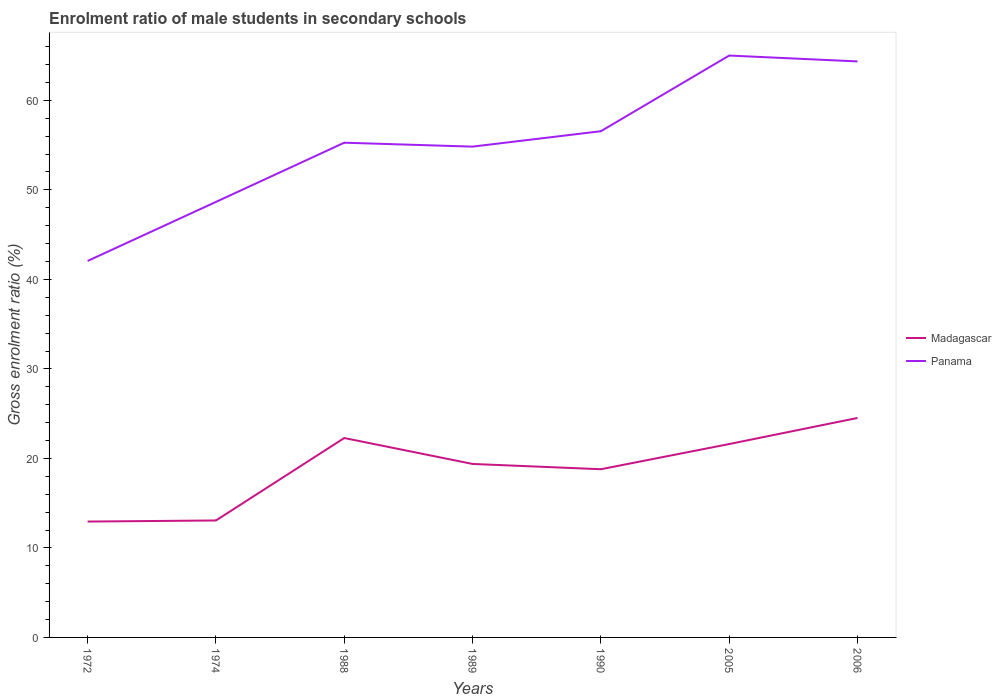How many different coloured lines are there?
Provide a succinct answer. 2. Does the line corresponding to Panama intersect with the line corresponding to Madagascar?
Your answer should be compact. No. Across all years, what is the maximum enrolment ratio of male students in secondary schools in Panama?
Provide a succinct answer. 42.06. In which year was the enrolment ratio of male students in secondary schools in Madagascar maximum?
Keep it short and to the point. 1972. What is the total enrolment ratio of male students in secondary schools in Panama in the graph?
Ensure brevity in your answer.  -6.59. What is the difference between the highest and the second highest enrolment ratio of male students in secondary schools in Madagascar?
Your response must be concise. 11.58. Does the graph contain any zero values?
Offer a terse response. No. Where does the legend appear in the graph?
Your response must be concise. Center right. How many legend labels are there?
Provide a short and direct response. 2. What is the title of the graph?
Keep it short and to the point. Enrolment ratio of male students in secondary schools. What is the Gross enrolment ratio (%) of Madagascar in 1972?
Make the answer very short. 12.94. What is the Gross enrolment ratio (%) of Panama in 1972?
Your response must be concise. 42.06. What is the Gross enrolment ratio (%) in Madagascar in 1974?
Ensure brevity in your answer.  13.07. What is the Gross enrolment ratio (%) in Panama in 1974?
Your answer should be compact. 48.66. What is the Gross enrolment ratio (%) of Madagascar in 1988?
Keep it short and to the point. 22.28. What is the Gross enrolment ratio (%) of Panama in 1988?
Your answer should be compact. 55.27. What is the Gross enrolment ratio (%) in Madagascar in 1989?
Make the answer very short. 19.38. What is the Gross enrolment ratio (%) of Panama in 1989?
Ensure brevity in your answer.  54.83. What is the Gross enrolment ratio (%) in Madagascar in 1990?
Offer a terse response. 18.79. What is the Gross enrolment ratio (%) of Panama in 1990?
Offer a very short reply. 56.56. What is the Gross enrolment ratio (%) in Madagascar in 2005?
Offer a terse response. 21.61. What is the Gross enrolment ratio (%) in Panama in 2005?
Provide a short and direct response. 65.01. What is the Gross enrolment ratio (%) in Madagascar in 2006?
Your answer should be very brief. 24.52. What is the Gross enrolment ratio (%) of Panama in 2006?
Offer a terse response. 64.35. Across all years, what is the maximum Gross enrolment ratio (%) in Madagascar?
Keep it short and to the point. 24.52. Across all years, what is the maximum Gross enrolment ratio (%) of Panama?
Give a very brief answer. 65.01. Across all years, what is the minimum Gross enrolment ratio (%) of Madagascar?
Provide a succinct answer. 12.94. Across all years, what is the minimum Gross enrolment ratio (%) in Panama?
Your response must be concise. 42.06. What is the total Gross enrolment ratio (%) in Madagascar in the graph?
Your answer should be compact. 132.59. What is the total Gross enrolment ratio (%) in Panama in the graph?
Make the answer very short. 386.74. What is the difference between the Gross enrolment ratio (%) in Madagascar in 1972 and that in 1974?
Keep it short and to the point. -0.12. What is the difference between the Gross enrolment ratio (%) of Panama in 1972 and that in 1974?
Give a very brief answer. -6.59. What is the difference between the Gross enrolment ratio (%) in Madagascar in 1972 and that in 1988?
Provide a succinct answer. -9.33. What is the difference between the Gross enrolment ratio (%) in Panama in 1972 and that in 1988?
Make the answer very short. -13.21. What is the difference between the Gross enrolment ratio (%) in Madagascar in 1972 and that in 1989?
Provide a succinct answer. -6.44. What is the difference between the Gross enrolment ratio (%) of Panama in 1972 and that in 1989?
Your answer should be compact. -12.77. What is the difference between the Gross enrolment ratio (%) of Madagascar in 1972 and that in 1990?
Your response must be concise. -5.85. What is the difference between the Gross enrolment ratio (%) of Panama in 1972 and that in 1990?
Ensure brevity in your answer.  -14.49. What is the difference between the Gross enrolment ratio (%) in Madagascar in 1972 and that in 2005?
Offer a terse response. -8.66. What is the difference between the Gross enrolment ratio (%) in Panama in 1972 and that in 2005?
Ensure brevity in your answer.  -22.95. What is the difference between the Gross enrolment ratio (%) of Madagascar in 1972 and that in 2006?
Offer a very short reply. -11.58. What is the difference between the Gross enrolment ratio (%) of Panama in 1972 and that in 2006?
Give a very brief answer. -22.29. What is the difference between the Gross enrolment ratio (%) in Madagascar in 1974 and that in 1988?
Keep it short and to the point. -9.21. What is the difference between the Gross enrolment ratio (%) in Panama in 1974 and that in 1988?
Your answer should be compact. -6.62. What is the difference between the Gross enrolment ratio (%) in Madagascar in 1974 and that in 1989?
Provide a succinct answer. -6.32. What is the difference between the Gross enrolment ratio (%) of Panama in 1974 and that in 1989?
Keep it short and to the point. -6.18. What is the difference between the Gross enrolment ratio (%) in Madagascar in 1974 and that in 1990?
Give a very brief answer. -5.73. What is the difference between the Gross enrolment ratio (%) of Panama in 1974 and that in 1990?
Your answer should be compact. -7.9. What is the difference between the Gross enrolment ratio (%) of Madagascar in 1974 and that in 2005?
Ensure brevity in your answer.  -8.54. What is the difference between the Gross enrolment ratio (%) of Panama in 1974 and that in 2005?
Provide a short and direct response. -16.35. What is the difference between the Gross enrolment ratio (%) of Madagascar in 1974 and that in 2006?
Your response must be concise. -11.45. What is the difference between the Gross enrolment ratio (%) in Panama in 1974 and that in 2006?
Your answer should be compact. -15.7. What is the difference between the Gross enrolment ratio (%) in Madagascar in 1988 and that in 1989?
Provide a succinct answer. 2.9. What is the difference between the Gross enrolment ratio (%) in Panama in 1988 and that in 1989?
Your answer should be compact. 0.44. What is the difference between the Gross enrolment ratio (%) of Madagascar in 1988 and that in 1990?
Give a very brief answer. 3.49. What is the difference between the Gross enrolment ratio (%) of Panama in 1988 and that in 1990?
Give a very brief answer. -1.28. What is the difference between the Gross enrolment ratio (%) in Madagascar in 1988 and that in 2005?
Offer a very short reply. 0.67. What is the difference between the Gross enrolment ratio (%) of Panama in 1988 and that in 2005?
Your answer should be very brief. -9.74. What is the difference between the Gross enrolment ratio (%) of Madagascar in 1988 and that in 2006?
Provide a succinct answer. -2.24. What is the difference between the Gross enrolment ratio (%) of Panama in 1988 and that in 2006?
Your answer should be compact. -9.08. What is the difference between the Gross enrolment ratio (%) of Madagascar in 1989 and that in 1990?
Offer a terse response. 0.59. What is the difference between the Gross enrolment ratio (%) in Panama in 1989 and that in 1990?
Provide a short and direct response. -1.72. What is the difference between the Gross enrolment ratio (%) of Madagascar in 1989 and that in 2005?
Offer a very short reply. -2.22. What is the difference between the Gross enrolment ratio (%) of Panama in 1989 and that in 2005?
Offer a very short reply. -10.17. What is the difference between the Gross enrolment ratio (%) in Madagascar in 1989 and that in 2006?
Make the answer very short. -5.14. What is the difference between the Gross enrolment ratio (%) in Panama in 1989 and that in 2006?
Your answer should be very brief. -9.52. What is the difference between the Gross enrolment ratio (%) in Madagascar in 1990 and that in 2005?
Give a very brief answer. -2.81. What is the difference between the Gross enrolment ratio (%) of Panama in 1990 and that in 2005?
Keep it short and to the point. -8.45. What is the difference between the Gross enrolment ratio (%) in Madagascar in 1990 and that in 2006?
Ensure brevity in your answer.  -5.73. What is the difference between the Gross enrolment ratio (%) in Panama in 1990 and that in 2006?
Your response must be concise. -7.8. What is the difference between the Gross enrolment ratio (%) in Madagascar in 2005 and that in 2006?
Ensure brevity in your answer.  -2.91. What is the difference between the Gross enrolment ratio (%) in Panama in 2005 and that in 2006?
Ensure brevity in your answer.  0.66. What is the difference between the Gross enrolment ratio (%) in Madagascar in 1972 and the Gross enrolment ratio (%) in Panama in 1974?
Your response must be concise. -35.71. What is the difference between the Gross enrolment ratio (%) in Madagascar in 1972 and the Gross enrolment ratio (%) in Panama in 1988?
Your answer should be very brief. -42.33. What is the difference between the Gross enrolment ratio (%) of Madagascar in 1972 and the Gross enrolment ratio (%) of Panama in 1989?
Your response must be concise. -41.89. What is the difference between the Gross enrolment ratio (%) of Madagascar in 1972 and the Gross enrolment ratio (%) of Panama in 1990?
Give a very brief answer. -43.61. What is the difference between the Gross enrolment ratio (%) in Madagascar in 1972 and the Gross enrolment ratio (%) in Panama in 2005?
Keep it short and to the point. -52.06. What is the difference between the Gross enrolment ratio (%) of Madagascar in 1972 and the Gross enrolment ratio (%) of Panama in 2006?
Make the answer very short. -51.41. What is the difference between the Gross enrolment ratio (%) of Madagascar in 1974 and the Gross enrolment ratio (%) of Panama in 1988?
Offer a very short reply. -42.21. What is the difference between the Gross enrolment ratio (%) of Madagascar in 1974 and the Gross enrolment ratio (%) of Panama in 1989?
Make the answer very short. -41.77. What is the difference between the Gross enrolment ratio (%) in Madagascar in 1974 and the Gross enrolment ratio (%) in Panama in 1990?
Provide a succinct answer. -43.49. What is the difference between the Gross enrolment ratio (%) in Madagascar in 1974 and the Gross enrolment ratio (%) in Panama in 2005?
Provide a succinct answer. -51.94. What is the difference between the Gross enrolment ratio (%) in Madagascar in 1974 and the Gross enrolment ratio (%) in Panama in 2006?
Provide a short and direct response. -51.29. What is the difference between the Gross enrolment ratio (%) in Madagascar in 1988 and the Gross enrolment ratio (%) in Panama in 1989?
Keep it short and to the point. -32.56. What is the difference between the Gross enrolment ratio (%) in Madagascar in 1988 and the Gross enrolment ratio (%) in Panama in 1990?
Ensure brevity in your answer.  -34.28. What is the difference between the Gross enrolment ratio (%) in Madagascar in 1988 and the Gross enrolment ratio (%) in Panama in 2005?
Keep it short and to the point. -42.73. What is the difference between the Gross enrolment ratio (%) in Madagascar in 1988 and the Gross enrolment ratio (%) in Panama in 2006?
Offer a terse response. -42.08. What is the difference between the Gross enrolment ratio (%) in Madagascar in 1989 and the Gross enrolment ratio (%) in Panama in 1990?
Ensure brevity in your answer.  -37.18. What is the difference between the Gross enrolment ratio (%) of Madagascar in 1989 and the Gross enrolment ratio (%) of Panama in 2005?
Keep it short and to the point. -45.63. What is the difference between the Gross enrolment ratio (%) of Madagascar in 1989 and the Gross enrolment ratio (%) of Panama in 2006?
Offer a very short reply. -44.97. What is the difference between the Gross enrolment ratio (%) in Madagascar in 1990 and the Gross enrolment ratio (%) in Panama in 2005?
Offer a terse response. -46.22. What is the difference between the Gross enrolment ratio (%) in Madagascar in 1990 and the Gross enrolment ratio (%) in Panama in 2006?
Your answer should be very brief. -45.56. What is the difference between the Gross enrolment ratio (%) of Madagascar in 2005 and the Gross enrolment ratio (%) of Panama in 2006?
Offer a terse response. -42.75. What is the average Gross enrolment ratio (%) of Madagascar per year?
Your answer should be very brief. 18.94. What is the average Gross enrolment ratio (%) of Panama per year?
Offer a very short reply. 55.25. In the year 1972, what is the difference between the Gross enrolment ratio (%) in Madagascar and Gross enrolment ratio (%) in Panama?
Your answer should be very brief. -29.12. In the year 1974, what is the difference between the Gross enrolment ratio (%) of Madagascar and Gross enrolment ratio (%) of Panama?
Provide a short and direct response. -35.59. In the year 1988, what is the difference between the Gross enrolment ratio (%) of Madagascar and Gross enrolment ratio (%) of Panama?
Provide a short and direct response. -32.99. In the year 1989, what is the difference between the Gross enrolment ratio (%) of Madagascar and Gross enrolment ratio (%) of Panama?
Keep it short and to the point. -35.45. In the year 1990, what is the difference between the Gross enrolment ratio (%) of Madagascar and Gross enrolment ratio (%) of Panama?
Provide a short and direct response. -37.76. In the year 2005, what is the difference between the Gross enrolment ratio (%) of Madagascar and Gross enrolment ratio (%) of Panama?
Give a very brief answer. -43.4. In the year 2006, what is the difference between the Gross enrolment ratio (%) of Madagascar and Gross enrolment ratio (%) of Panama?
Offer a very short reply. -39.83. What is the ratio of the Gross enrolment ratio (%) in Panama in 1972 to that in 1974?
Make the answer very short. 0.86. What is the ratio of the Gross enrolment ratio (%) of Madagascar in 1972 to that in 1988?
Offer a very short reply. 0.58. What is the ratio of the Gross enrolment ratio (%) of Panama in 1972 to that in 1988?
Give a very brief answer. 0.76. What is the ratio of the Gross enrolment ratio (%) of Madagascar in 1972 to that in 1989?
Keep it short and to the point. 0.67. What is the ratio of the Gross enrolment ratio (%) in Panama in 1972 to that in 1989?
Ensure brevity in your answer.  0.77. What is the ratio of the Gross enrolment ratio (%) in Madagascar in 1972 to that in 1990?
Provide a short and direct response. 0.69. What is the ratio of the Gross enrolment ratio (%) in Panama in 1972 to that in 1990?
Provide a short and direct response. 0.74. What is the ratio of the Gross enrolment ratio (%) of Madagascar in 1972 to that in 2005?
Your answer should be compact. 0.6. What is the ratio of the Gross enrolment ratio (%) of Panama in 1972 to that in 2005?
Keep it short and to the point. 0.65. What is the ratio of the Gross enrolment ratio (%) in Madagascar in 1972 to that in 2006?
Provide a short and direct response. 0.53. What is the ratio of the Gross enrolment ratio (%) of Panama in 1972 to that in 2006?
Provide a succinct answer. 0.65. What is the ratio of the Gross enrolment ratio (%) in Madagascar in 1974 to that in 1988?
Your response must be concise. 0.59. What is the ratio of the Gross enrolment ratio (%) of Panama in 1974 to that in 1988?
Offer a terse response. 0.88. What is the ratio of the Gross enrolment ratio (%) in Madagascar in 1974 to that in 1989?
Make the answer very short. 0.67. What is the ratio of the Gross enrolment ratio (%) in Panama in 1974 to that in 1989?
Your response must be concise. 0.89. What is the ratio of the Gross enrolment ratio (%) in Madagascar in 1974 to that in 1990?
Provide a succinct answer. 0.7. What is the ratio of the Gross enrolment ratio (%) of Panama in 1974 to that in 1990?
Keep it short and to the point. 0.86. What is the ratio of the Gross enrolment ratio (%) in Madagascar in 1974 to that in 2005?
Give a very brief answer. 0.6. What is the ratio of the Gross enrolment ratio (%) in Panama in 1974 to that in 2005?
Ensure brevity in your answer.  0.75. What is the ratio of the Gross enrolment ratio (%) of Madagascar in 1974 to that in 2006?
Offer a very short reply. 0.53. What is the ratio of the Gross enrolment ratio (%) of Panama in 1974 to that in 2006?
Ensure brevity in your answer.  0.76. What is the ratio of the Gross enrolment ratio (%) in Madagascar in 1988 to that in 1989?
Provide a short and direct response. 1.15. What is the ratio of the Gross enrolment ratio (%) of Panama in 1988 to that in 1989?
Your answer should be very brief. 1.01. What is the ratio of the Gross enrolment ratio (%) in Madagascar in 1988 to that in 1990?
Your answer should be compact. 1.19. What is the ratio of the Gross enrolment ratio (%) of Panama in 1988 to that in 1990?
Keep it short and to the point. 0.98. What is the ratio of the Gross enrolment ratio (%) of Madagascar in 1988 to that in 2005?
Give a very brief answer. 1.03. What is the ratio of the Gross enrolment ratio (%) of Panama in 1988 to that in 2005?
Keep it short and to the point. 0.85. What is the ratio of the Gross enrolment ratio (%) of Madagascar in 1988 to that in 2006?
Your response must be concise. 0.91. What is the ratio of the Gross enrolment ratio (%) in Panama in 1988 to that in 2006?
Your answer should be very brief. 0.86. What is the ratio of the Gross enrolment ratio (%) in Madagascar in 1989 to that in 1990?
Provide a short and direct response. 1.03. What is the ratio of the Gross enrolment ratio (%) of Panama in 1989 to that in 1990?
Give a very brief answer. 0.97. What is the ratio of the Gross enrolment ratio (%) of Madagascar in 1989 to that in 2005?
Offer a very short reply. 0.9. What is the ratio of the Gross enrolment ratio (%) of Panama in 1989 to that in 2005?
Offer a terse response. 0.84. What is the ratio of the Gross enrolment ratio (%) in Madagascar in 1989 to that in 2006?
Provide a short and direct response. 0.79. What is the ratio of the Gross enrolment ratio (%) of Panama in 1989 to that in 2006?
Keep it short and to the point. 0.85. What is the ratio of the Gross enrolment ratio (%) of Madagascar in 1990 to that in 2005?
Offer a very short reply. 0.87. What is the ratio of the Gross enrolment ratio (%) in Panama in 1990 to that in 2005?
Provide a succinct answer. 0.87. What is the ratio of the Gross enrolment ratio (%) in Madagascar in 1990 to that in 2006?
Give a very brief answer. 0.77. What is the ratio of the Gross enrolment ratio (%) of Panama in 1990 to that in 2006?
Keep it short and to the point. 0.88. What is the ratio of the Gross enrolment ratio (%) of Madagascar in 2005 to that in 2006?
Keep it short and to the point. 0.88. What is the ratio of the Gross enrolment ratio (%) in Panama in 2005 to that in 2006?
Provide a succinct answer. 1.01. What is the difference between the highest and the second highest Gross enrolment ratio (%) of Madagascar?
Keep it short and to the point. 2.24. What is the difference between the highest and the second highest Gross enrolment ratio (%) in Panama?
Your answer should be compact. 0.66. What is the difference between the highest and the lowest Gross enrolment ratio (%) in Madagascar?
Offer a terse response. 11.58. What is the difference between the highest and the lowest Gross enrolment ratio (%) in Panama?
Your answer should be very brief. 22.95. 